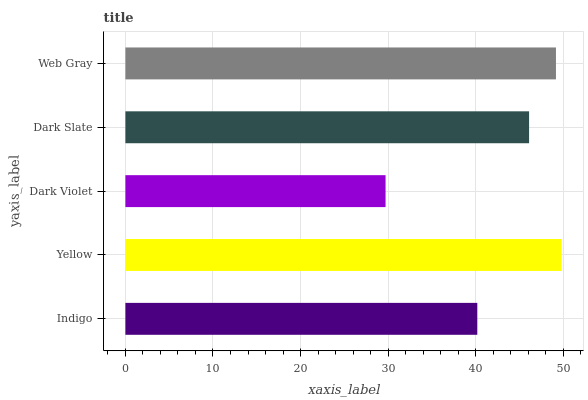Is Dark Violet the minimum?
Answer yes or no. Yes. Is Yellow the maximum?
Answer yes or no. Yes. Is Yellow the minimum?
Answer yes or no. No. Is Dark Violet the maximum?
Answer yes or no. No. Is Yellow greater than Dark Violet?
Answer yes or no. Yes. Is Dark Violet less than Yellow?
Answer yes or no. Yes. Is Dark Violet greater than Yellow?
Answer yes or no. No. Is Yellow less than Dark Violet?
Answer yes or no. No. Is Dark Slate the high median?
Answer yes or no. Yes. Is Dark Slate the low median?
Answer yes or no. Yes. Is Indigo the high median?
Answer yes or no. No. Is Dark Violet the low median?
Answer yes or no. No. 